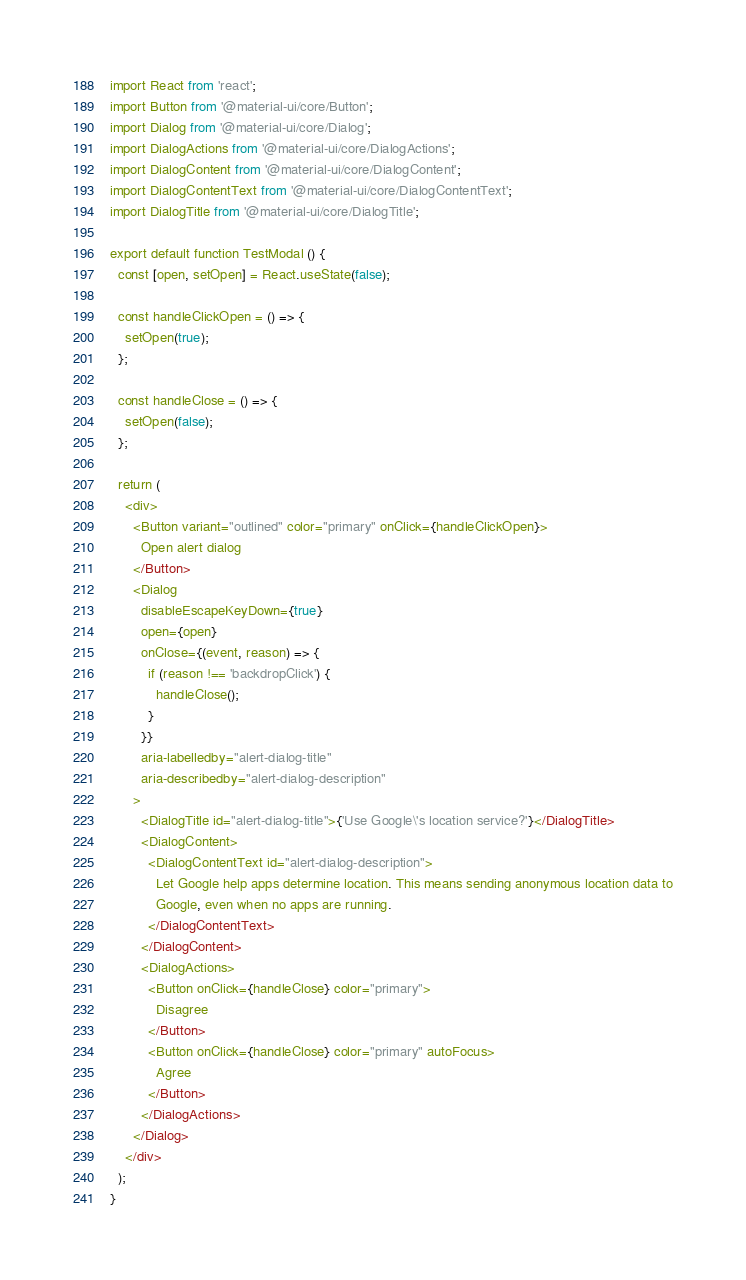Convert code to text. <code><loc_0><loc_0><loc_500><loc_500><_TypeScript_>import React from 'react';
import Button from '@material-ui/core/Button';
import Dialog from '@material-ui/core/Dialog';
import DialogActions from '@material-ui/core/DialogActions';
import DialogContent from '@material-ui/core/DialogContent';
import DialogContentText from '@material-ui/core/DialogContentText';
import DialogTitle from '@material-ui/core/DialogTitle';

export default function TestModal () {
  const [open, setOpen] = React.useState(false);

  const handleClickOpen = () => {
    setOpen(true);
  };

  const handleClose = () => {
    setOpen(false);
  };

  return (
    <div>
      <Button variant="outlined" color="primary" onClick={handleClickOpen}>
        Open alert dialog
      </Button>
      <Dialog
        disableEscapeKeyDown={true}
        open={open}
        onClose={(event, reason) => {
          if (reason !== 'backdropClick') {
            handleClose();
          }
        }}
        aria-labelledby="alert-dialog-title"
        aria-describedby="alert-dialog-description"
      >
        <DialogTitle id="alert-dialog-title">{'Use Google\'s location service?'}</DialogTitle>
        <DialogContent>
          <DialogContentText id="alert-dialog-description">
            Let Google help apps determine location. This means sending anonymous location data to
            Google, even when no apps are running.
          </DialogContentText>
        </DialogContent>
        <DialogActions>
          <Button onClick={handleClose} color="primary">
            Disagree
          </Button>
          <Button onClick={handleClose} color="primary" autoFocus>
            Agree
          </Button>
        </DialogActions>
      </Dialog>
    </div>
  );
}
</code> 